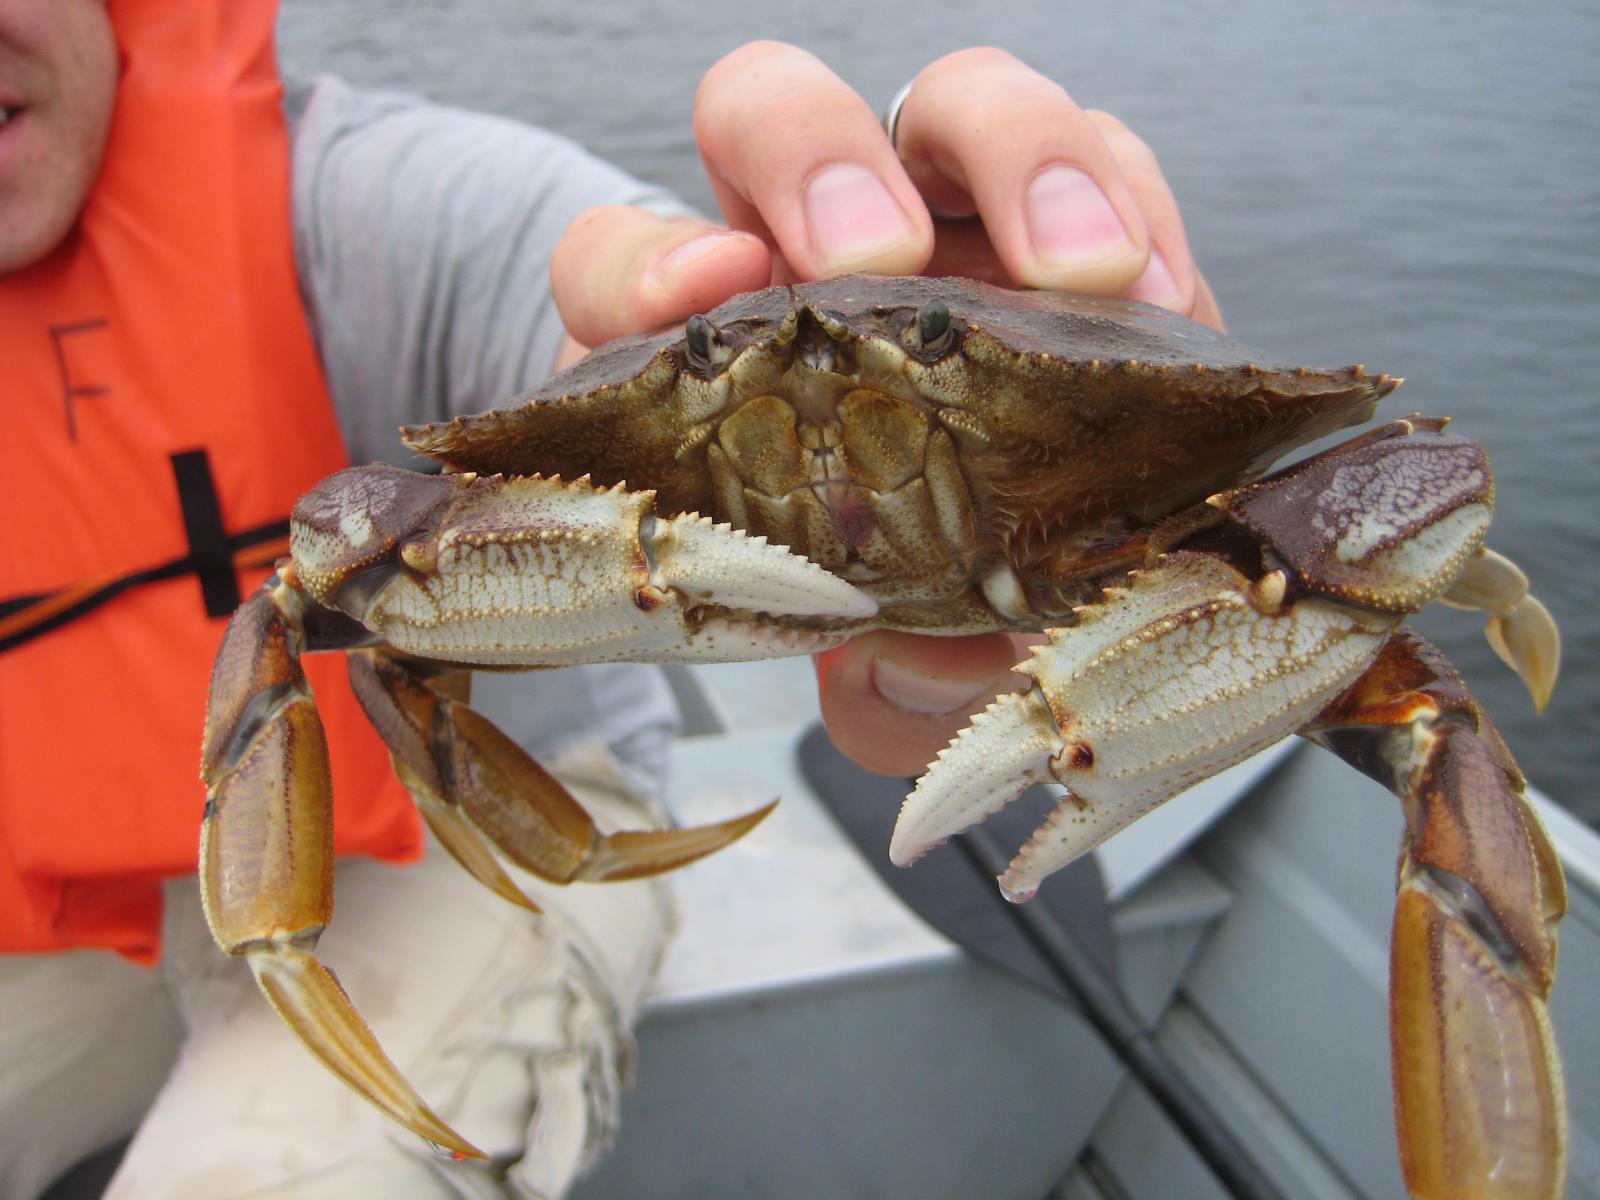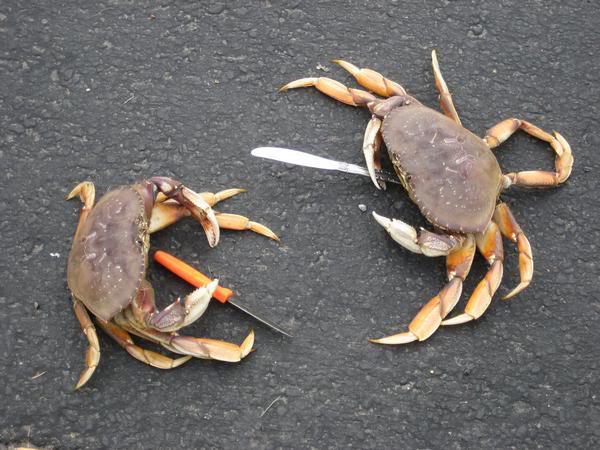The first image is the image on the left, the second image is the image on the right. Assess this claim about the two images: "Someone is holding the crab in the image on the right.". Correct or not? Answer yes or no. No. The first image is the image on the left, the second image is the image on the right. Considering the images on both sides, is "The left image features one hand holding a forward-facing crab in front of a body of water." valid? Answer yes or no. Yes. 